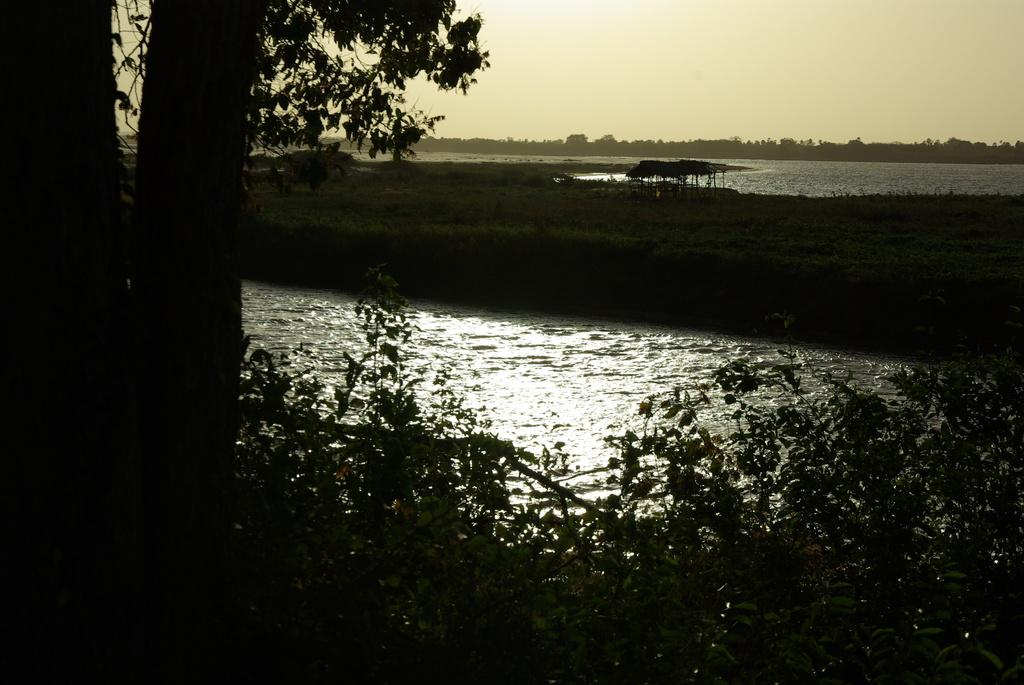What type of vegetation can be seen in the image? There are trees and plants in the image. What natural element is visible in the image? There is water visible in the image. What type of shelter is present in the image? There is a tent in the image. What is visible at the top of the image? The sky is visible at the top of the image. What unit of measurement is used to determine the depth of the sea in the image? There is no sea present in the image, so no unit of measurement is needed to determine its depth. How is the sea being controlled in the image? There is no sea or any indication of control in the image. 